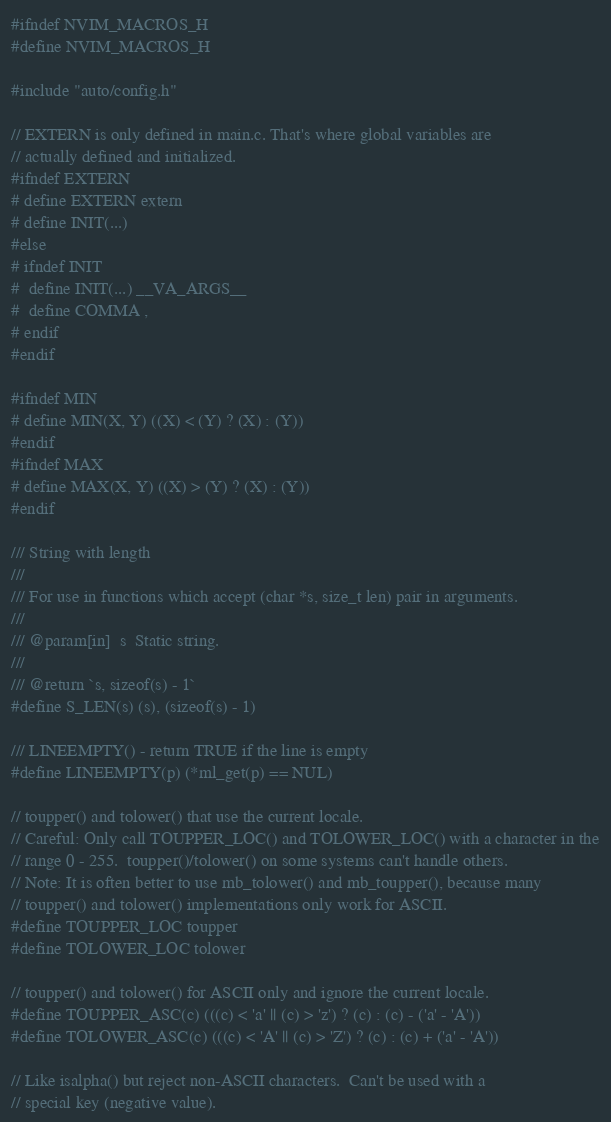<code> <loc_0><loc_0><loc_500><loc_500><_C_>#ifndef NVIM_MACROS_H
#define NVIM_MACROS_H

#include "auto/config.h"

// EXTERN is only defined in main.c. That's where global variables are
// actually defined and initialized.
#ifndef EXTERN
# define EXTERN extern
# define INIT(...)
#else
# ifndef INIT
#  define INIT(...) __VA_ARGS__
#  define COMMA ,
# endif
#endif

#ifndef MIN
# define MIN(X, Y) ((X) < (Y) ? (X) : (Y))
#endif
#ifndef MAX
# define MAX(X, Y) ((X) > (Y) ? (X) : (Y))
#endif

/// String with length
///
/// For use in functions which accept (char *s, size_t len) pair in arguments.
///
/// @param[in]  s  Static string.
///
/// @return `s, sizeof(s) - 1`
#define S_LEN(s) (s), (sizeof(s) - 1)

/// LINEEMPTY() - return TRUE if the line is empty
#define LINEEMPTY(p) (*ml_get(p) == NUL)

// toupper() and tolower() that use the current locale.
// Careful: Only call TOUPPER_LOC() and TOLOWER_LOC() with a character in the
// range 0 - 255.  toupper()/tolower() on some systems can't handle others.
// Note: It is often better to use mb_tolower() and mb_toupper(), because many
// toupper() and tolower() implementations only work for ASCII.
#define TOUPPER_LOC toupper
#define TOLOWER_LOC tolower

// toupper() and tolower() for ASCII only and ignore the current locale.
#define TOUPPER_ASC(c) (((c) < 'a' || (c) > 'z') ? (c) : (c) - ('a' - 'A'))
#define TOLOWER_ASC(c) (((c) < 'A' || (c) > 'Z') ? (c) : (c) + ('a' - 'A'))

// Like isalpha() but reject non-ASCII characters.  Can't be used with a
// special key (negative value).</code> 